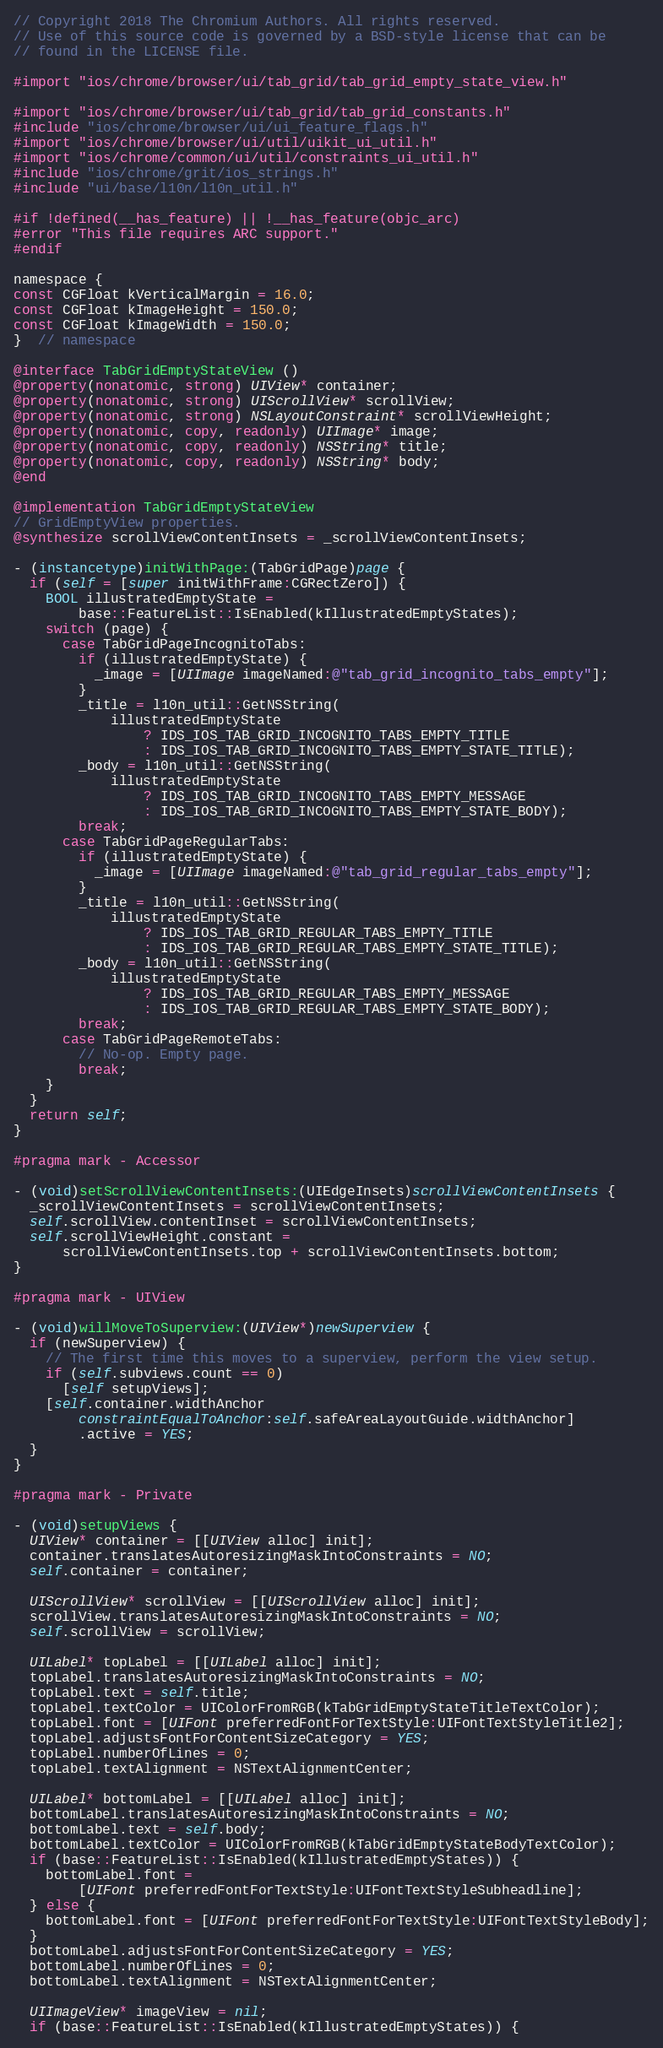<code> <loc_0><loc_0><loc_500><loc_500><_ObjectiveC_>// Copyright 2018 The Chromium Authors. All rights reserved.
// Use of this source code is governed by a BSD-style license that can be
// found in the LICENSE file.

#import "ios/chrome/browser/ui/tab_grid/tab_grid_empty_state_view.h"

#import "ios/chrome/browser/ui/tab_grid/tab_grid_constants.h"
#include "ios/chrome/browser/ui/ui_feature_flags.h"
#import "ios/chrome/browser/ui/util/uikit_ui_util.h"
#import "ios/chrome/common/ui/util/constraints_ui_util.h"
#include "ios/chrome/grit/ios_strings.h"
#include "ui/base/l10n/l10n_util.h"

#if !defined(__has_feature) || !__has_feature(objc_arc)
#error "This file requires ARC support."
#endif

namespace {
const CGFloat kVerticalMargin = 16.0;
const CGFloat kImageHeight = 150.0;
const CGFloat kImageWidth = 150.0;
}  // namespace

@interface TabGridEmptyStateView ()
@property(nonatomic, strong) UIView* container;
@property(nonatomic, strong) UIScrollView* scrollView;
@property(nonatomic, strong) NSLayoutConstraint* scrollViewHeight;
@property(nonatomic, copy, readonly) UIImage* image;
@property(nonatomic, copy, readonly) NSString* title;
@property(nonatomic, copy, readonly) NSString* body;
@end

@implementation TabGridEmptyStateView
// GridEmptyView properties.
@synthesize scrollViewContentInsets = _scrollViewContentInsets;

- (instancetype)initWithPage:(TabGridPage)page {
  if (self = [super initWithFrame:CGRectZero]) {
    BOOL illustratedEmptyState =
        base::FeatureList::IsEnabled(kIllustratedEmptyStates);
    switch (page) {
      case TabGridPageIncognitoTabs:
        if (illustratedEmptyState) {
          _image = [UIImage imageNamed:@"tab_grid_incognito_tabs_empty"];
        }
        _title = l10n_util::GetNSString(
            illustratedEmptyState
                ? IDS_IOS_TAB_GRID_INCOGNITO_TABS_EMPTY_TITLE
                : IDS_IOS_TAB_GRID_INCOGNITO_TABS_EMPTY_STATE_TITLE);
        _body = l10n_util::GetNSString(
            illustratedEmptyState
                ? IDS_IOS_TAB_GRID_INCOGNITO_TABS_EMPTY_MESSAGE
                : IDS_IOS_TAB_GRID_INCOGNITO_TABS_EMPTY_STATE_BODY);
        break;
      case TabGridPageRegularTabs:
        if (illustratedEmptyState) {
          _image = [UIImage imageNamed:@"tab_grid_regular_tabs_empty"];
        }
        _title = l10n_util::GetNSString(
            illustratedEmptyState
                ? IDS_IOS_TAB_GRID_REGULAR_TABS_EMPTY_TITLE
                : IDS_IOS_TAB_GRID_REGULAR_TABS_EMPTY_STATE_TITLE);
        _body = l10n_util::GetNSString(
            illustratedEmptyState
                ? IDS_IOS_TAB_GRID_REGULAR_TABS_EMPTY_MESSAGE
                : IDS_IOS_TAB_GRID_REGULAR_TABS_EMPTY_STATE_BODY);
        break;
      case TabGridPageRemoteTabs:
        // No-op. Empty page.
        break;
    }
  }
  return self;
}

#pragma mark - Accessor

- (void)setScrollViewContentInsets:(UIEdgeInsets)scrollViewContentInsets {
  _scrollViewContentInsets = scrollViewContentInsets;
  self.scrollView.contentInset = scrollViewContentInsets;
  self.scrollViewHeight.constant =
      scrollViewContentInsets.top + scrollViewContentInsets.bottom;
}

#pragma mark - UIView

- (void)willMoveToSuperview:(UIView*)newSuperview {
  if (newSuperview) {
    // The first time this moves to a superview, perform the view setup.
    if (self.subviews.count == 0)
      [self setupViews];
    [self.container.widthAnchor
        constraintEqualToAnchor:self.safeAreaLayoutGuide.widthAnchor]
        .active = YES;
  }
}

#pragma mark - Private

- (void)setupViews {
  UIView* container = [[UIView alloc] init];
  container.translatesAutoresizingMaskIntoConstraints = NO;
  self.container = container;

  UIScrollView* scrollView = [[UIScrollView alloc] init];
  scrollView.translatesAutoresizingMaskIntoConstraints = NO;
  self.scrollView = scrollView;

  UILabel* topLabel = [[UILabel alloc] init];
  topLabel.translatesAutoresizingMaskIntoConstraints = NO;
  topLabel.text = self.title;
  topLabel.textColor = UIColorFromRGB(kTabGridEmptyStateTitleTextColor);
  topLabel.font = [UIFont preferredFontForTextStyle:UIFontTextStyleTitle2];
  topLabel.adjustsFontForContentSizeCategory = YES;
  topLabel.numberOfLines = 0;
  topLabel.textAlignment = NSTextAlignmentCenter;

  UILabel* bottomLabel = [[UILabel alloc] init];
  bottomLabel.translatesAutoresizingMaskIntoConstraints = NO;
  bottomLabel.text = self.body;
  bottomLabel.textColor = UIColorFromRGB(kTabGridEmptyStateBodyTextColor);
  if (base::FeatureList::IsEnabled(kIllustratedEmptyStates)) {
    bottomLabel.font =
        [UIFont preferredFontForTextStyle:UIFontTextStyleSubheadline];
  } else {
    bottomLabel.font = [UIFont preferredFontForTextStyle:UIFontTextStyleBody];
  }
  bottomLabel.adjustsFontForContentSizeCategory = YES;
  bottomLabel.numberOfLines = 0;
  bottomLabel.textAlignment = NSTextAlignmentCenter;

  UIImageView* imageView = nil;
  if (base::FeatureList::IsEnabled(kIllustratedEmptyStates)) {</code> 